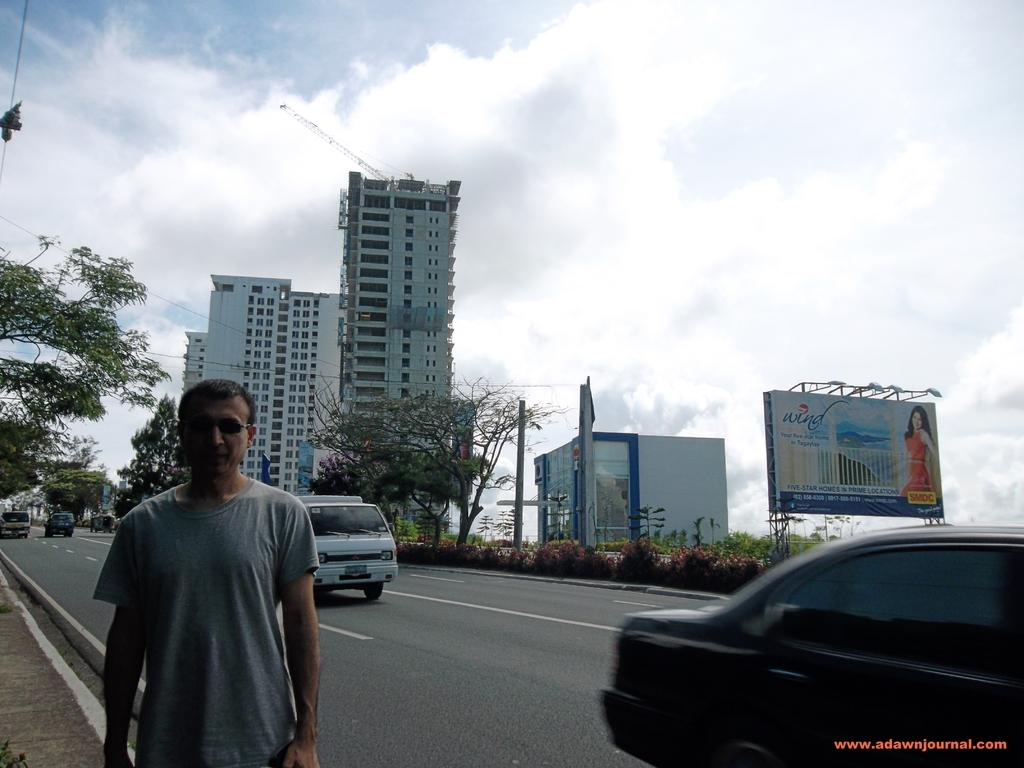What is the main subject of the image? There is a man standing in the image. What can be seen on the road in the image? There are vehicles on the road in the image. What type of vegetation is visible in the image? There are plants and trees visible in the image. What is present in the image that might be used for advertising? There is a hoarding in the image. What else can be seen in the background of the image? There are buildings and the sky visible in the background of the image. What type of pen is the man holding in the image? There is no pen visible in the image; the man is not holding anything. How many wheels can be seen on the vehicles in the image? The image does not provide enough detail to count the number of wheels on the vehicles. 